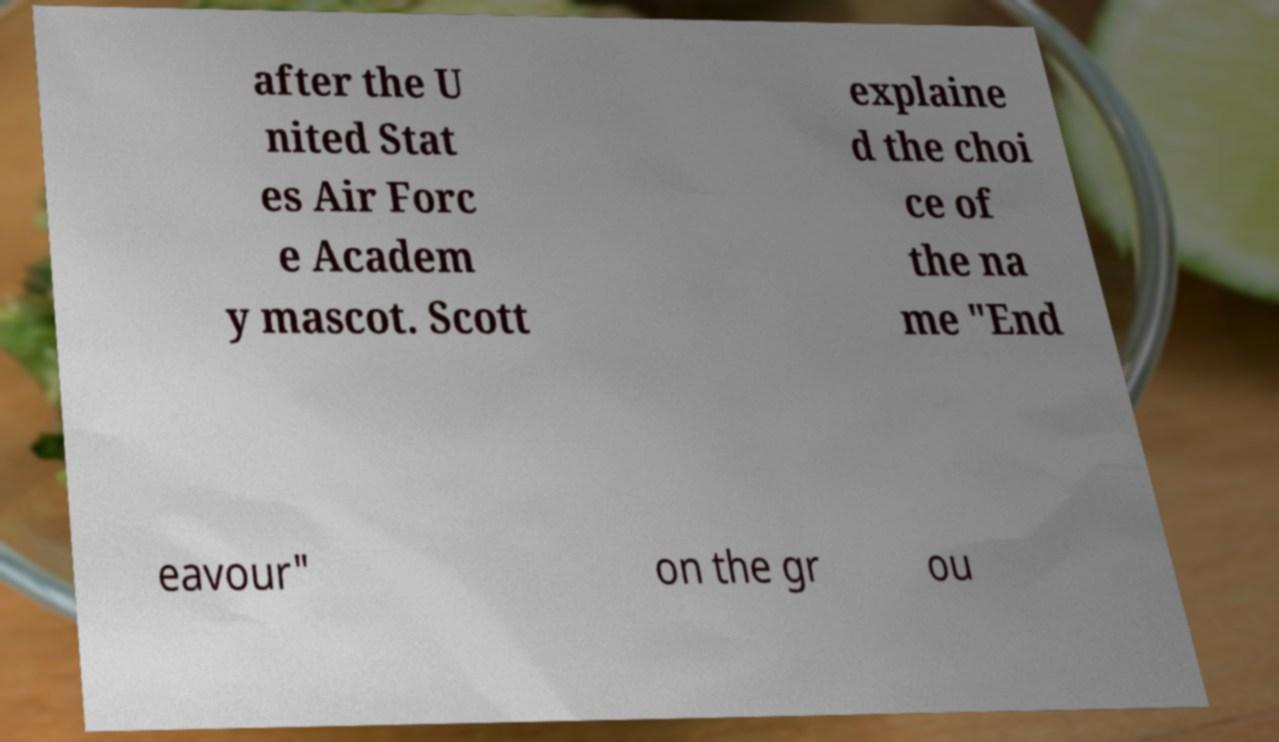What messages or text are displayed in this image? I need them in a readable, typed format. after the U nited Stat es Air Forc e Academ y mascot. Scott explaine d the choi ce of the na me "End eavour" on the gr ou 